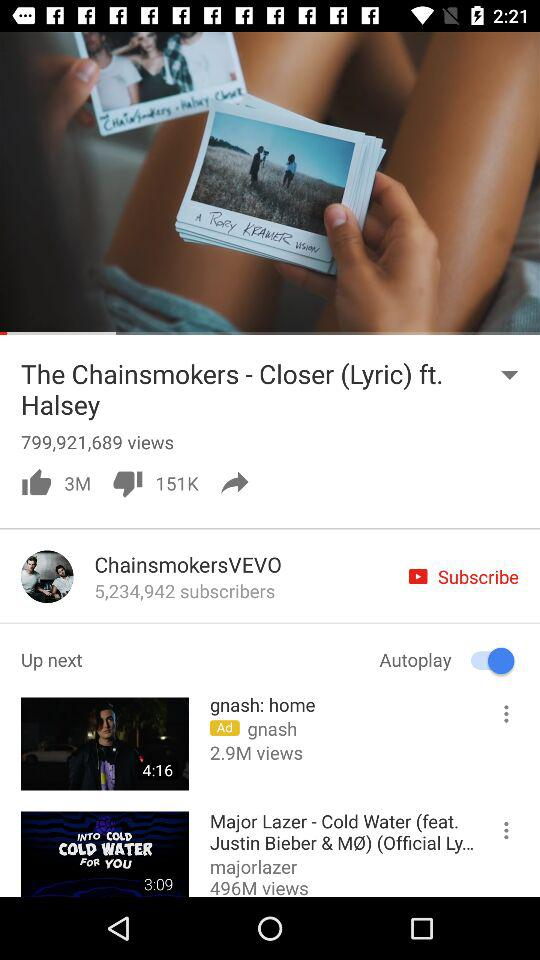How many views are on "Major Lazer - Cold Water"? There are 496 million views. 